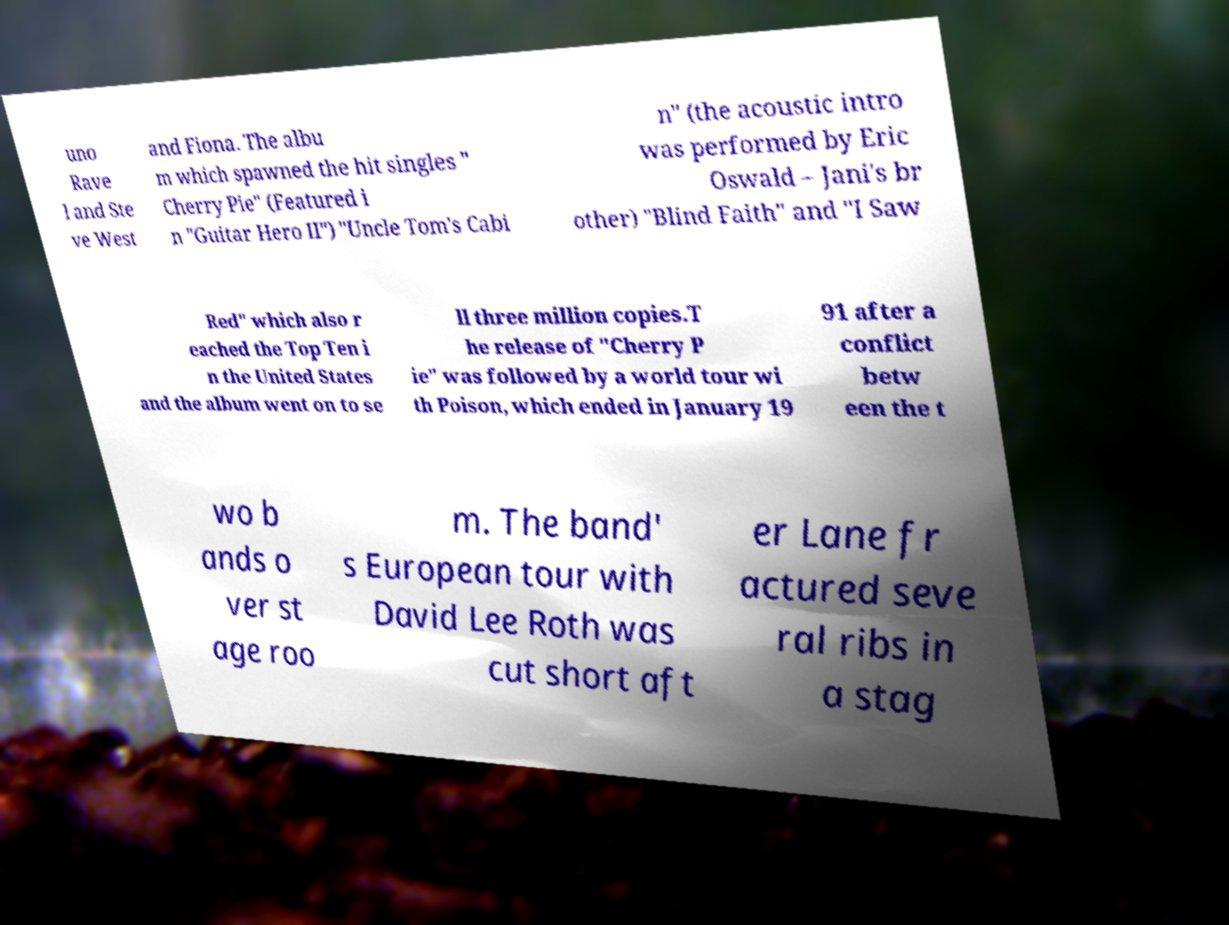There's text embedded in this image that I need extracted. Can you transcribe it verbatim? uno Rave l and Ste ve West and Fiona. The albu m which spawned the hit singles " Cherry Pie" (Featured i n "Guitar Hero II") "Uncle Tom's Cabi n" (the acoustic intro was performed by Eric Oswald – Jani's br other) "Blind Faith" and "I Saw Red" which also r eached the Top Ten i n the United States and the album went on to se ll three million copies.T he release of "Cherry P ie" was followed by a world tour wi th Poison, which ended in January 19 91 after a conflict betw een the t wo b ands o ver st age roo m. The band' s European tour with David Lee Roth was cut short aft er Lane fr actured seve ral ribs in a stag 